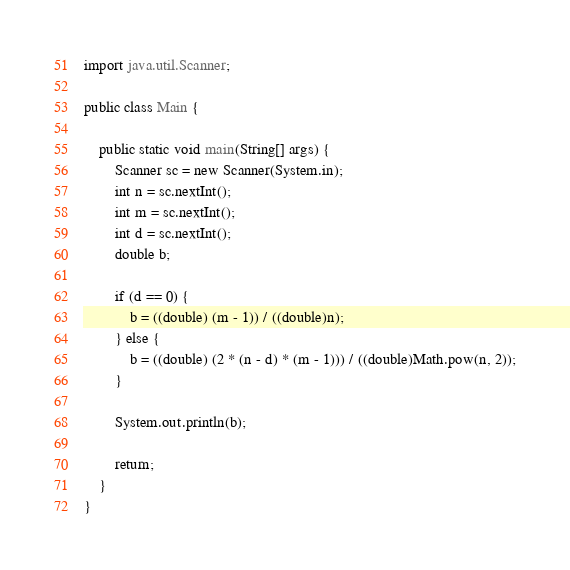<code> <loc_0><loc_0><loc_500><loc_500><_Java_>import java.util.Scanner;

public class Main {

	public static void main(String[] args) {
		Scanner sc = new Scanner(System.in);
		int n = sc.nextInt();
		int m = sc.nextInt();
		int d = sc.nextInt();
		double b;

		if (d == 0) {
			b = ((double) (m - 1)) / ((double)n);
		} else {
			b = ((double) (2 * (n - d) * (m - 1))) / ((double)Math.pow(n, 2));
		}

		System.out.println(b);

		return;
	}
}
</code> 